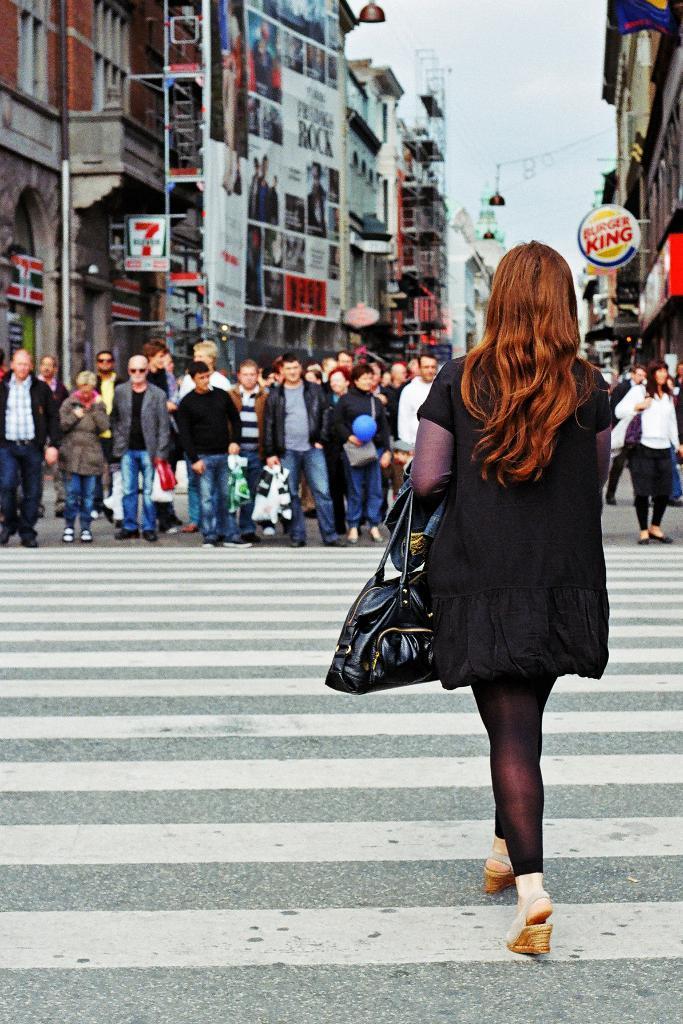Please provide a concise description of this image. In this image in the foreground there is one woman who is walking and she is holding a handbag, and in the background there are some people who are standing and also there are some buildings, poles and some wires. At the bottom there is a walkway. 